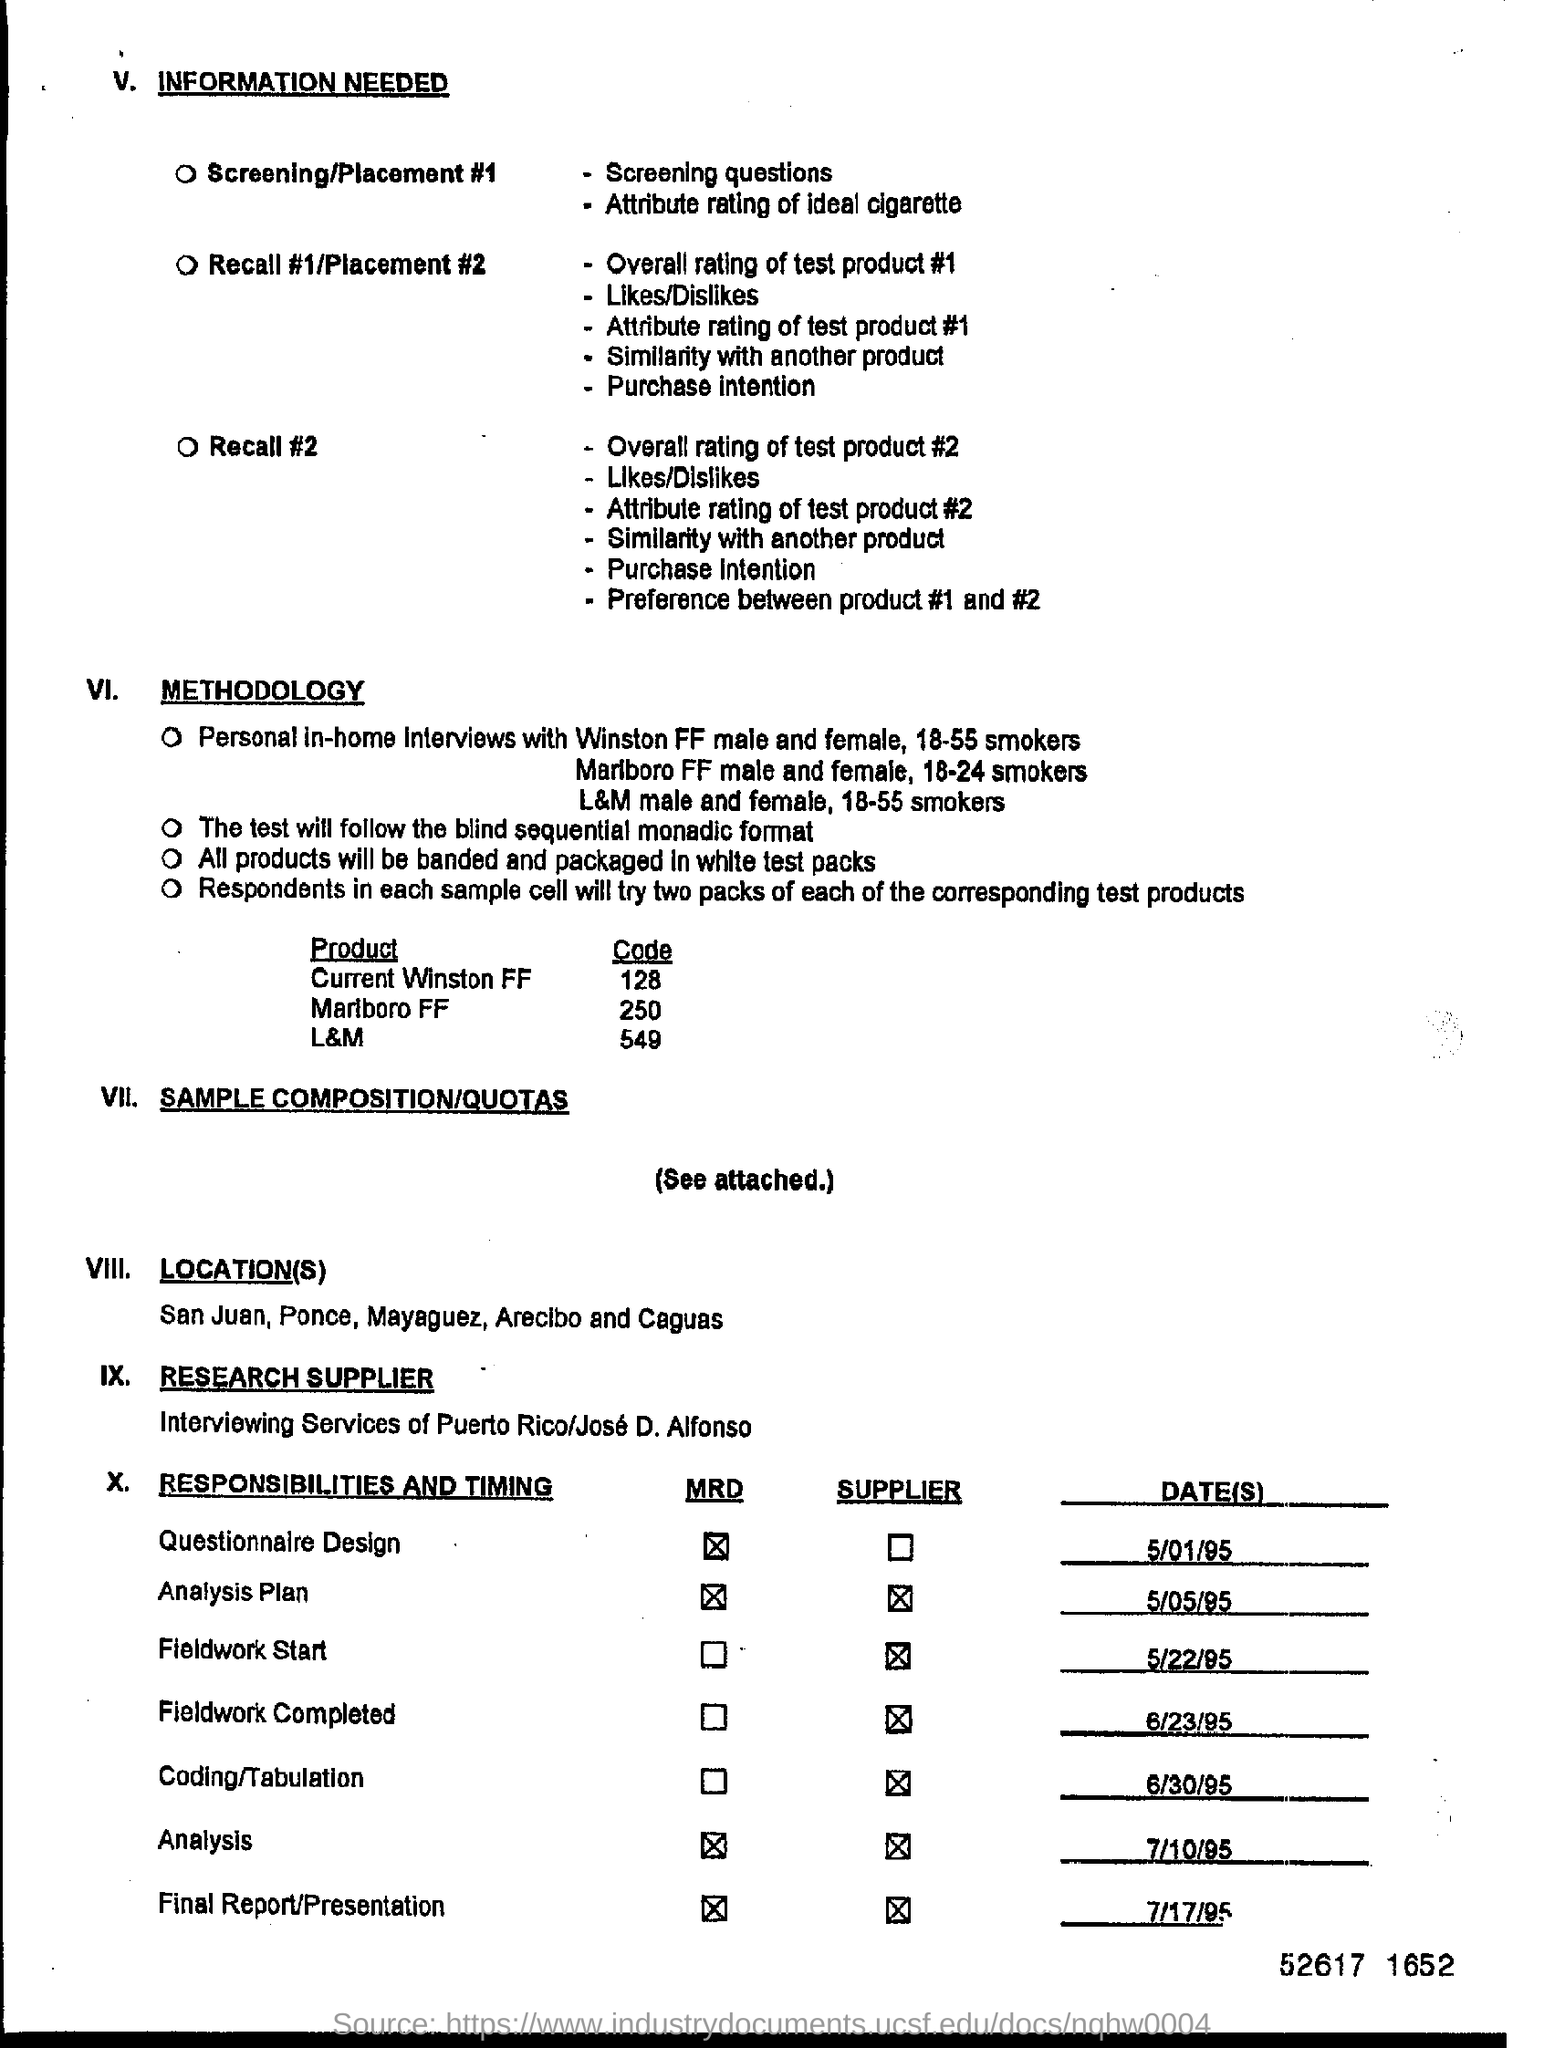What is the code for the product "current winston ff" ?
Your answer should be compact. 128. Mention the date for final report/ presentation ?
Offer a terse response. 7/17/95. 